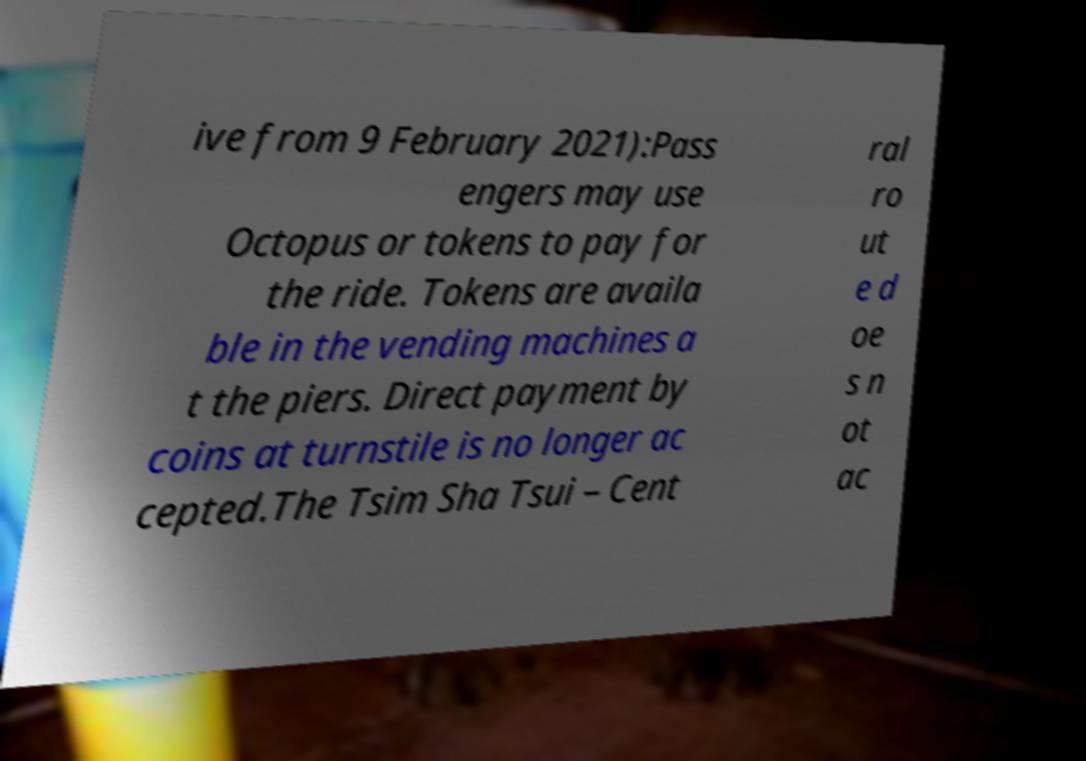Could you extract and type out the text from this image? ive from 9 February 2021):Pass engers may use Octopus or tokens to pay for the ride. Tokens are availa ble in the vending machines a t the piers. Direct payment by coins at turnstile is no longer ac cepted.The Tsim Sha Tsui – Cent ral ro ut e d oe s n ot ac 